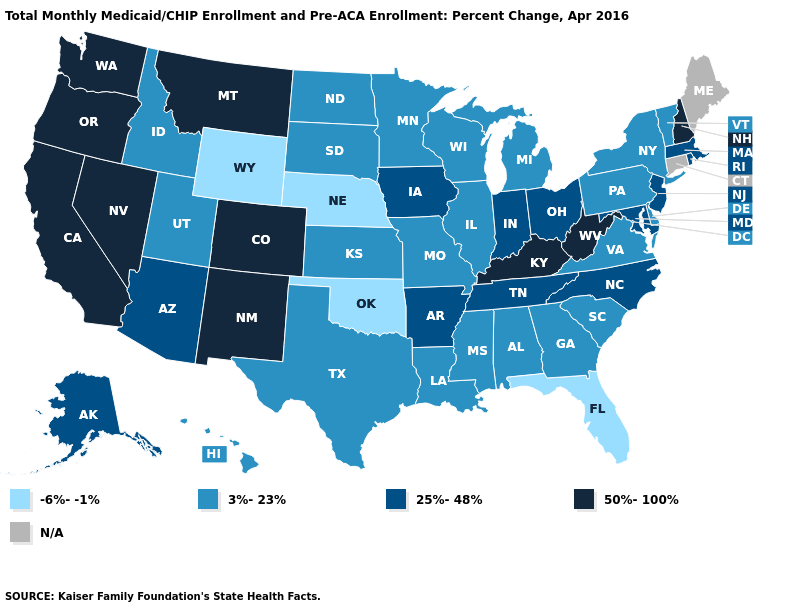Is the legend a continuous bar?
Keep it brief. No. Which states hav the highest value in the MidWest?
Answer briefly. Indiana, Iowa, Ohio. Does the first symbol in the legend represent the smallest category?
Write a very short answer. Yes. Name the states that have a value in the range 25%-48%?
Write a very short answer. Alaska, Arizona, Arkansas, Indiana, Iowa, Maryland, Massachusetts, New Jersey, North Carolina, Ohio, Rhode Island, Tennessee. Does Nebraska have the lowest value in the MidWest?
Write a very short answer. Yes. What is the highest value in states that border West Virginia?
Concise answer only. 50%-100%. Name the states that have a value in the range -6%--1%?
Write a very short answer. Florida, Nebraska, Oklahoma, Wyoming. Does the first symbol in the legend represent the smallest category?
Give a very brief answer. Yes. Which states have the lowest value in the South?
Give a very brief answer. Florida, Oklahoma. Name the states that have a value in the range 50%-100%?
Concise answer only. California, Colorado, Kentucky, Montana, Nevada, New Hampshire, New Mexico, Oregon, Washington, West Virginia. How many symbols are there in the legend?
Concise answer only. 5. Name the states that have a value in the range N/A?
Answer briefly. Connecticut, Maine. What is the value of Virginia?
Write a very short answer. 3%-23%. What is the value of Wisconsin?
Quick response, please. 3%-23%. What is the value of Colorado?
Short answer required. 50%-100%. 